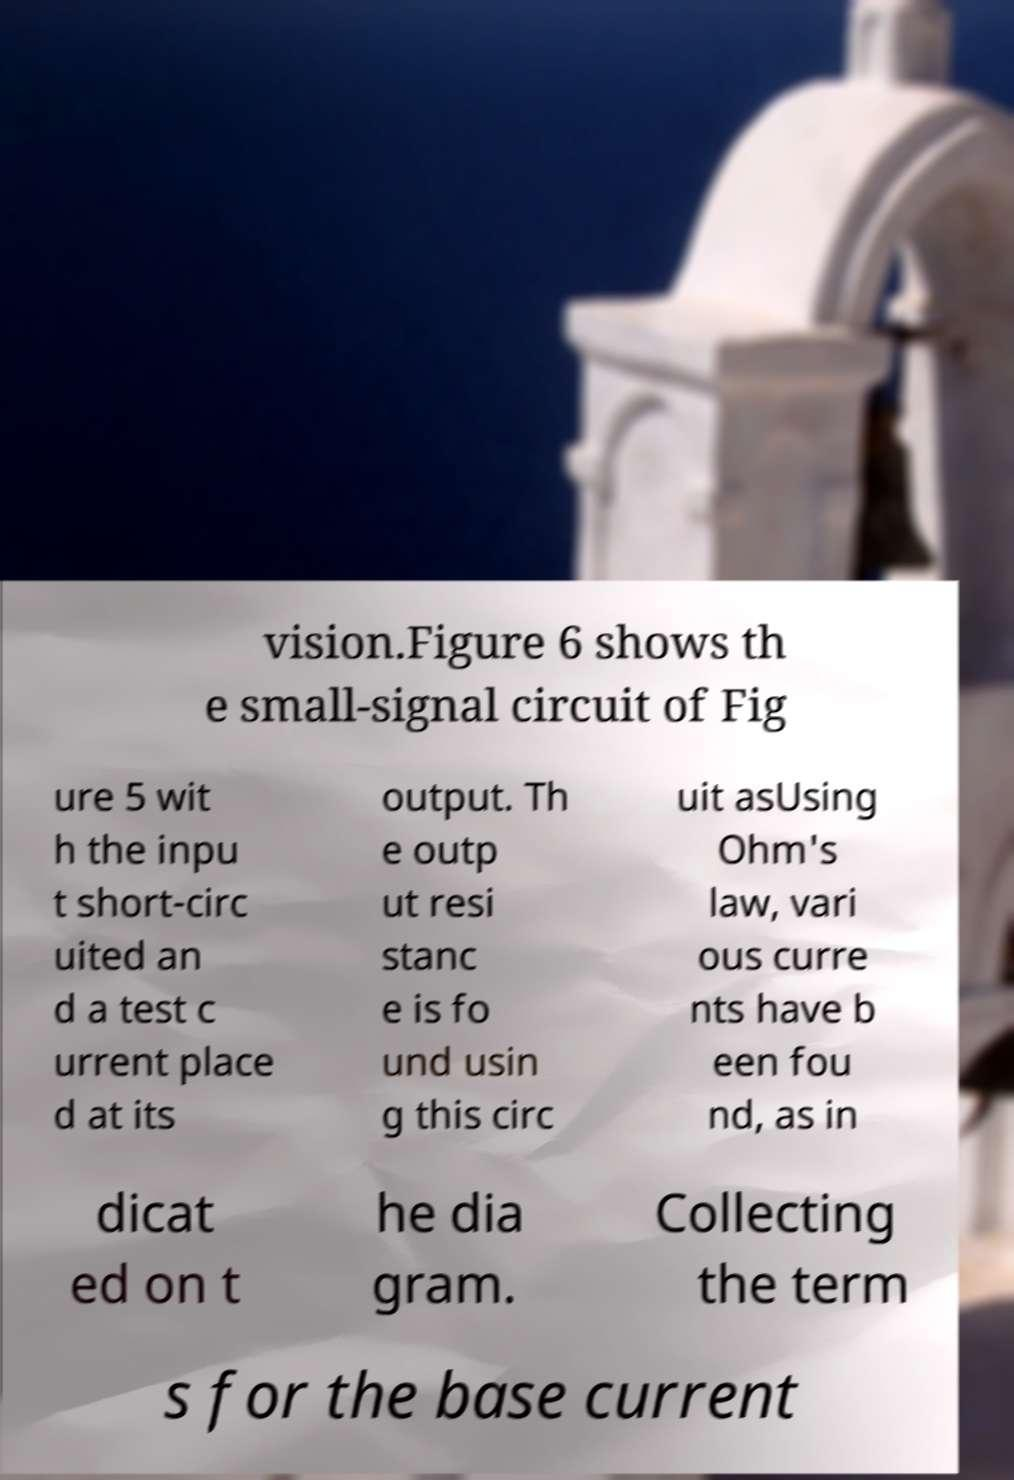What messages or text are displayed in this image? I need them in a readable, typed format. vision.Figure 6 shows th e small-signal circuit of Fig ure 5 wit h the inpu t short-circ uited an d a test c urrent place d at its output. Th e outp ut resi stanc e is fo und usin g this circ uit asUsing Ohm's law, vari ous curre nts have b een fou nd, as in dicat ed on t he dia gram. Collecting the term s for the base current 